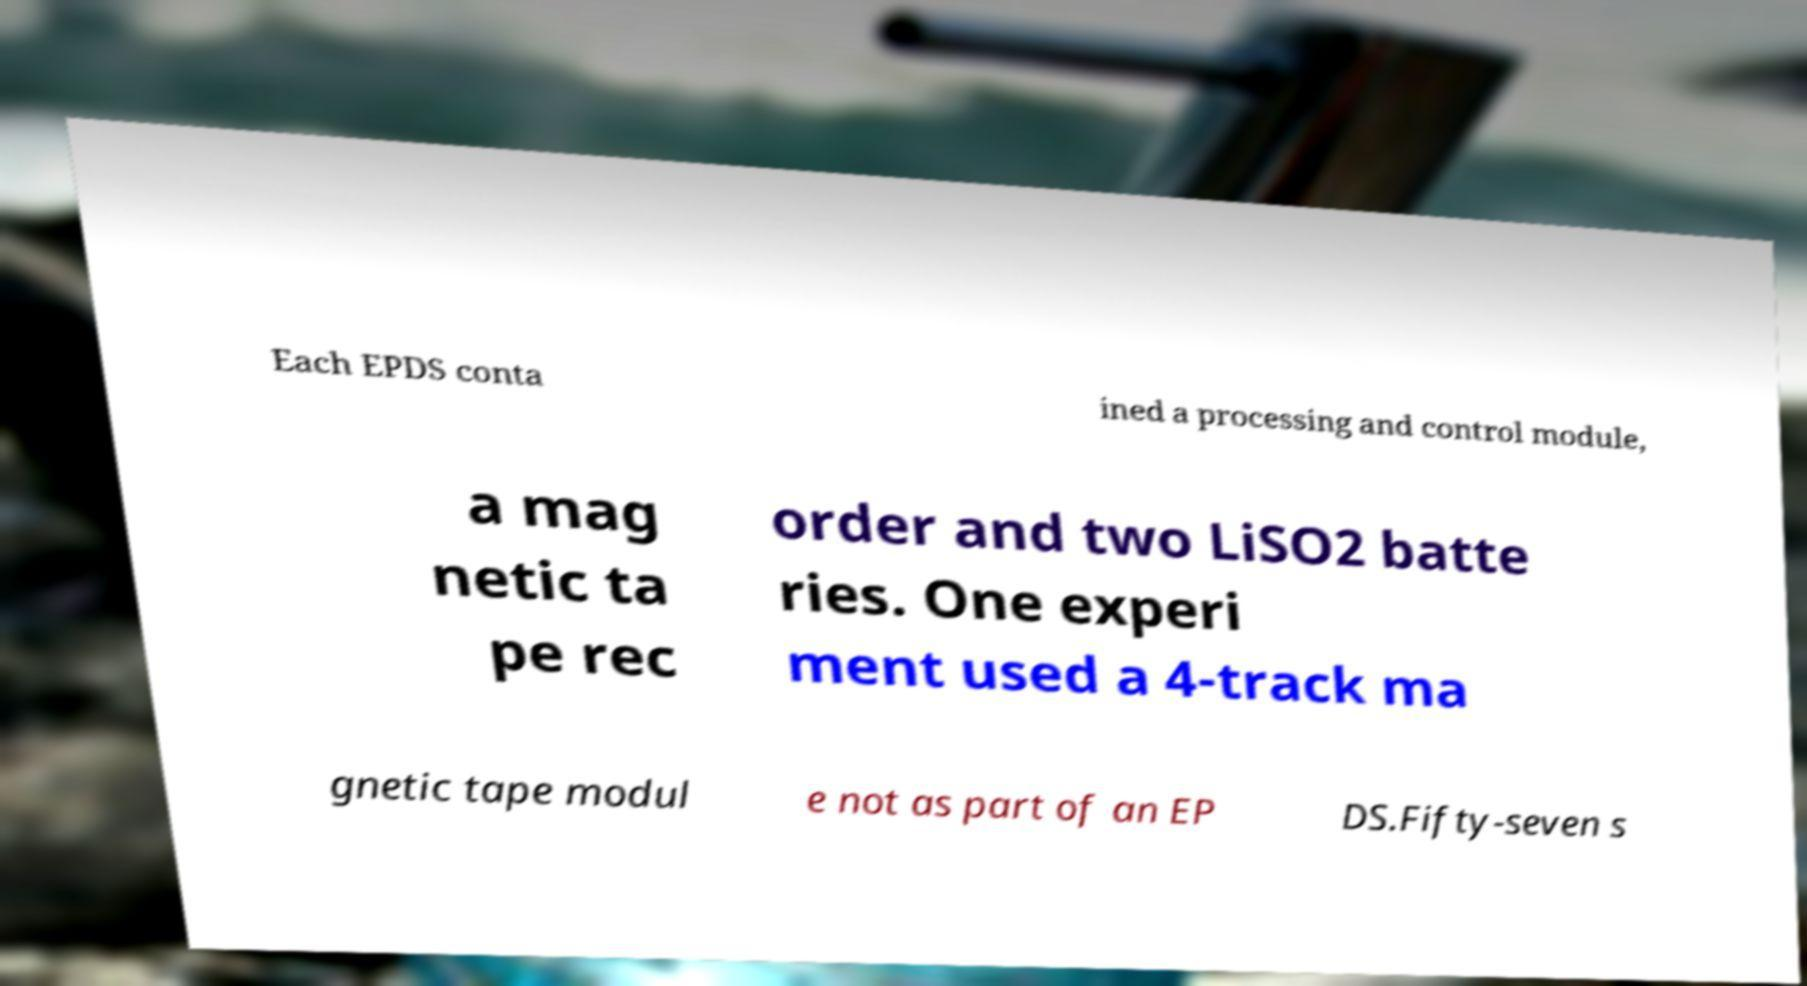There's text embedded in this image that I need extracted. Can you transcribe it verbatim? Each EPDS conta ined a processing and control module, a mag netic ta pe rec order and two LiSO2 batte ries. One experi ment used a 4-track ma gnetic tape modul e not as part of an EP DS.Fifty-seven s 